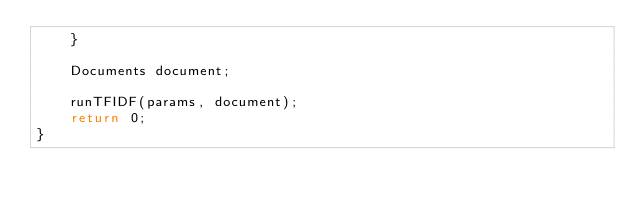<code> <loc_0><loc_0><loc_500><loc_500><_C++_>    }
    
    Documents document;

    runTFIDF(params, document);
    return 0;
}
</code> 